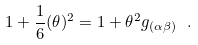<formula> <loc_0><loc_0><loc_500><loc_500>1 + \frac { 1 } { 6 } ( \theta ) ^ { 2 } = 1 + \theta ^ { 2 } g _ { ( \alpha \beta ) } \ .</formula> 